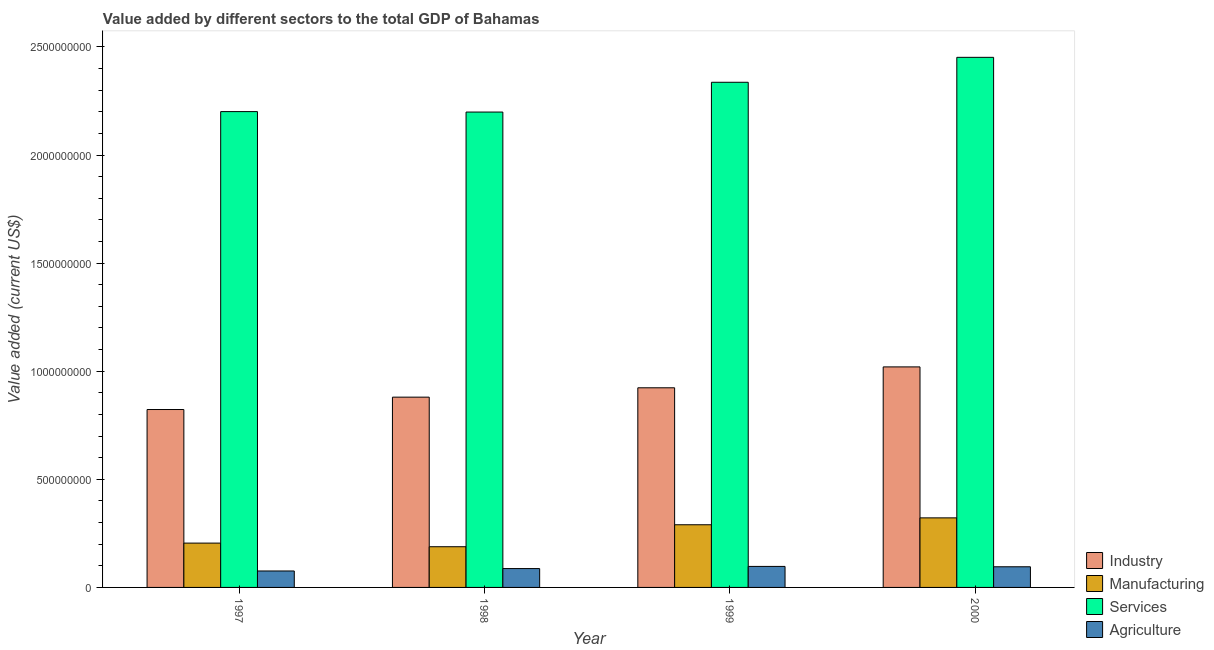How many groups of bars are there?
Offer a very short reply. 4. Are the number of bars on each tick of the X-axis equal?
Make the answer very short. Yes. How many bars are there on the 1st tick from the left?
Your answer should be compact. 4. How many bars are there on the 4th tick from the right?
Make the answer very short. 4. In how many cases, is the number of bars for a given year not equal to the number of legend labels?
Your answer should be compact. 0. What is the value added by industrial sector in 2000?
Give a very brief answer. 1.02e+09. Across all years, what is the maximum value added by agricultural sector?
Your response must be concise. 9.72e+07. Across all years, what is the minimum value added by agricultural sector?
Keep it short and to the point. 7.61e+07. In which year was the value added by manufacturing sector maximum?
Your answer should be very brief. 2000. What is the total value added by manufacturing sector in the graph?
Offer a very short reply. 1.00e+09. What is the difference between the value added by agricultural sector in 1997 and that in 2000?
Keep it short and to the point. -1.94e+07. What is the difference between the value added by manufacturing sector in 1998 and the value added by agricultural sector in 2000?
Your answer should be compact. -1.34e+08. What is the average value added by manufacturing sector per year?
Give a very brief answer. 2.51e+08. In the year 1997, what is the difference between the value added by agricultural sector and value added by industrial sector?
Your response must be concise. 0. What is the ratio of the value added by industrial sector in 1997 to that in 1998?
Your answer should be compact. 0.93. Is the difference between the value added by industrial sector in 1998 and 1999 greater than the difference between the value added by services sector in 1998 and 1999?
Give a very brief answer. No. What is the difference between the highest and the second highest value added by agricultural sector?
Ensure brevity in your answer.  1.66e+06. What is the difference between the highest and the lowest value added by agricultural sector?
Provide a short and direct response. 2.11e+07. Is the sum of the value added by manufacturing sector in 1999 and 2000 greater than the maximum value added by agricultural sector across all years?
Give a very brief answer. Yes. What does the 3rd bar from the left in 1997 represents?
Your answer should be very brief. Services. What does the 3rd bar from the right in 2000 represents?
Your response must be concise. Manufacturing. How many bars are there?
Your answer should be compact. 16. How many years are there in the graph?
Your answer should be very brief. 4. What is the difference between two consecutive major ticks on the Y-axis?
Provide a succinct answer. 5.00e+08. Does the graph contain grids?
Make the answer very short. No. How are the legend labels stacked?
Offer a terse response. Vertical. What is the title of the graph?
Your answer should be very brief. Value added by different sectors to the total GDP of Bahamas. Does "Financial sector" appear as one of the legend labels in the graph?
Ensure brevity in your answer.  No. What is the label or title of the Y-axis?
Provide a short and direct response. Value added (current US$). What is the Value added (current US$) in Industry in 1997?
Your answer should be very brief. 8.23e+08. What is the Value added (current US$) in Manufacturing in 1997?
Your answer should be compact. 2.05e+08. What is the Value added (current US$) in Services in 1997?
Ensure brevity in your answer.  2.20e+09. What is the Value added (current US$) of Agriculture in 1997?
Ensure brevity in your answer.  7.61e+07. What is the Value added (current US$) in Industry in 1998?
Your answer should be compact. 8.80e+08. What is the Value added (current US$) in Manufacturing in 1998?
Keep it short and to the point. 1.88e+08. What is the Value added (current US$) of Services in 1998?
Your response must be concise. 2.20e+09. What is the Value added (current US$) in Agriculture in 1998?
Keep it short and to the point. 8.72e+07. What is the Value added (current US$) of Industry in 1999?
Your response must be concise. 9.23e+08. What is the Value added (current US$) in Manufacturing in 1999?
Your answer should be very brief. 2.90e+08. What is the Value added (current US$) in Services in 1999?
Offer a terse response. 2.34e+09. What is the Value added (current US$) of Agriculture in 1999?
Ensure brevity in your answer.  9.72e+07. What is the Value added (current US$) of Industry in 2000?
Offer a terse response. 1.02e+09. What is the Value added (current US$) in Manufacturing in 2000?
Keep it short and to the point. 3.22e+08. What is the Value added (current US$) in Services in 2000?
Make the answer very short. 2.45e+09. What is the Value added (current US$) of Agriculture in 2000?
Give a very brief answer. 9.55e+07. Across all years, what is the maximum Value added (current US$) in Industry?
Your answer should be very brief. 1.02e+09. Across all years, what is the maximum Value added (current US$) in Manufacturing?
Ensure brevity in your answer.  3.22e+08. Across all years, what is the maximum Value added (current US$) of Services?
Your response must be concise. 2.45e+09. Across all years, what is the maximum Value added (current US$) of Agriculture?
Your response must be concise. 9.72e+07. Across all years, what is the minimum Value added (current US$) in Industry?
Make the answer very short. 8.23e+08. Across all years, what is the minimum Value added (current US$) of Manufacturing?
Provide a succinct answer. 1.88e+08. Across all years, what is the minimum Value added (current US$) of Services?
Give a very brief answer. 2.20e+09. Across all years, what is the minimum Value added (current US$) of Agriculture?
Offer a very short reply. 7.61e+07. What is the total Value added (current US$) in Industry in the graph?
Provide a succinct answer. 3.65e+09. What is the total Value added (current US$) of Manufacturing in the graph?
Give a very brief answer. 1.00e+09. What is the total Value added (current US$) in Services in the graph?
Keep it short and to the point. 9.19e+09. What is the total Value added (current US$) in Agriculture in the graph?
Ensure brevity in your answer.  3.56e+08. What is the difference between the Value added (current US$) in Industry in 1997 and that in 1998?
Offer a terse response. -5.72e+07. What is the difference between the Value added (current US$) of Manufacturing in 1997 and that in 1998?
Offer a terse response. 1.68e+07. What is the difference between the Value added (current US$) of Services in 1997 and that in 1998?
Provide a short and direct response. 2.08e+06. What is the difference between the Value added (current US$) in Agriculture in 1997 and that in 1998?
Keep it short and to the point. -1.11e+07. What is the difference between the Value added (current US$) of Industry in 1997 and that in 1999?
Keep it short and to the point. -1.00e+08. What is the difference between the Value added (current US$) in Manufacturing in 1997 and that in 1999?
Provide a short and direct response. -8.48e+07. What is the difference between the Value added (current US$) in Services in 1997 and that in 1999?
Give a very brief answer. -1.36e+08. What is the difference between the Value added (current US$) in Agriculture in 1997 and that in 1999?
Provide a short and direct response. -2.11e+07. What is the difference between the Value added (current US$) of Industry in 1997 and that in 2000?
Your answer should be compact. -1.97e+08. What is the difference between the Value added (current US$) in Manufacturing in 1997 and that in 2000?
Your response must be concise. -1.17e+08. What is the difference between the Value added (current US$) of Services in 1997 and that in 2000?
Your answer should be very brief. -2.51e+08. What is the difference between the Value added (current US$) of Agriculture in 1997 and that in 2000?
Your answer should be very brief. -1.94e+07. What is the difference between the Value added (current US$) of Industry in 1998 and that in 1999?
Make the answer very short. -4.33e+07. What is the difference between the Value added (current US$) of Manufacturing in 1998 and that in 1999?
Give a very brief answer. -1.02e+08. What is the difference between the Value added (current US$) in Services in 1998 and that in 1999?
Your answer should be compact. -1.38e+08. What is the difference between the Value added (current US$) of Agriculture in 1998 and that in 1999?
Offer a very short reply. -1.00e+07. What is the difference between the Value added (current US$) in Industry in 1998 and that in 2000?
Offer a very short reply. -1.40e+08. What is the difference between the Value added (current US$) in Manufacturing in 1998 and that in 2000?
Your response must be concise. -1.34e+08. What is the difference between the Value added (current US$) in Services in 1998 and that in 2000?
Offer a terse response. -2.53e+08. What is the difference between the Value added (current US$) in Agriculture in 1998 and that in 2000?
Offer a terse response. -8.35e+06. What is the difference between the Value added (current US$) of Industry in 1999 and that in 2000?
Make the answer very short. -9.66e+07. What is the difference between the Value added (current US$) of Manufacturing in 1999 and that in 2000?
Keep it short and to the point. -3.19e+07. What is the difference between the Value added (current US$) in Services in 1999 and that in 2000?
Offer a very short reply. -1.15e+08. What is the difference between the Value added (current US$) of Agriculture in 1999 and that in 2000?
Your response must be concise. 1.66e+06. What is the difference between the Value added (current US$) in Industry in 1997 and the Value added (current US$) in Manufacturing in 1998?
Your response must be concise. 6.35e+08. What is the difference between the Value added (current US$) of Industry in 1997 and the Value added (current US$) of Services in 1998?
Provide a succinct answer. -1.38e+09. What is the difference between the Value added (current US$) in Industry in 1997 and the Value added (current US$) in Agriculture in 1998?
Your answer should be compact. 7.36e+08. What is the difference between the Value added (current US$) of Manufacturing in 1997 and the Value added (current US$) of Services in 1998?
Give a very brief answer. -1.99e+09. What is the difference between the Value added (current US$) of Manufacturing in 1997 and the Value added (current US$) of Agriculture in 1998?
Provide a short and direct response. 1.18e+08. What is the difference between the Value added (current US$) in Services in 1997 and the Value added (current US$) in Agriculture in 1998?
Your answer should be compact. 2.11e+09. What is the difference between the Value added (current US$) of Industry in 1997 and the Value added (current US$) of Manufacturing in 1999?
Your answer should be compact. 5.33e+08. What is the difference between the Value added (current US$) of Industry in 1997 and the Value added (current US$) of Services in 1999?
Your response must be concise. -1.51e+09. What is the difference between the Value added (current US$) of Industry in 1997 and the Value added (current US$) of Agriculture in 1999?
Keep it short and to the point. 7.26e+08. What is the difference between the Value added (current US$) in Manufacturing in 1997 and the Value added (current US$) in Services in 1999?
Your answer should be very brief. -2.13e+09. What is the difference between the Value added (current US$) in Manufacturing in 1997 and the Value added (current US$) in Agriculture in 1999?
Provide a succinct answer. 1.08e+08. What is the difference between the Value added (current US$) in Services in 1997 and the Value added (current US$) in Agriculture in 1999?
Keep it short and to the point. 2.10e+09. What is the difference between the Value added (current US$) of Industry in 1997 and the Value added (current US$) of Manufacturing in 2000?
Your response must be concise. 5.01e+08. What is the difference between the Value added (current US$) of Industry in 1997 and the Value added (current US$) of Services in 2000?
Your answer should be compact. -1.63e+09. What is the difference between the Value added (current US$) of Industry in 1997 and the Value added (current US$) of Agriculture in 2000?
Give a very brief answer. 7.27e+08. What is the difference between the Value added (current US$) in Manufacturing in 1997 and the Value added (current US$) in Services in 2000?
Your response must be concise. -2.25e+09. What is the difference between the Value added (current US$) in Manufacturing in 1997 and the Value added (current US$) in Agriculture in 2000?
Your answer should be very brief. 1.09e+08. What is the difference between the Value added (current US$) of Services in 1997 and the Value added (current US$) of Agriculture in 2000?
Keep it short and to the point. 2.11e+09. What is the difference between the Value added (current US$) in Industry in 1998 and the Value added (current US$) in Manufacturing in 1999?
Keep it short and to the point. 5.90e+08. What is the difference between the Value added (current US$) in Industry in 1998 and the Value added (current US$) in Services in 1999?
Your answer should be compact. -1.46e+09. What is the difference between the Value added (current US$) of Industry in 1998 and the Value added (current US$) of Agriculture in 1999?
Ensure brevity in your answer.  7.83e+08. What is the difference between the Value added (current US$) in Manufacturing in 1998 and the Value added (current US$) in Services in 1999?
Your response must be concise. -2.15e+09. What is the difference between the Value added (current US$) in Manufacturing in 1998 and the Value added (current US$) in Agriculture in 1999?
Offer a terse response. 9.10e+07. What is the difference between the Value added (current US$) in Services in 1998 and the Value added (current US$) in Agriculture in 1999?
Your answer should be compact. 2.10e+09. What is the difference between the Value added (current US$) in Industry in 1998 and the Value added (current US$) in Manufacturing in 2000?
Provide a short and direct response. 5.58e+08. What is the difference between the Value added (current US$) in Industry in 1998 and the Value added (current US$) in Services in 2000?
Provide a succinct answer. -1.57e+09. What is the difference between the Value added (current US$) in Industry in 1998 and the Value added (current US$) in Agriculture in 2000?
Provide a short and direct response. 7.85e+08. What is the difference between the Value added (current US$) of Manufacturing in 1998 and the Value added (current US$) of Services in 2000?
Provide a succinct answer. -2.26e+09. What is the difference between the Value added (current US$) of Manufacturing in 1998 and the Value added (current US$) of Agriculture in 2000?
Provide a succinct answer. 9.27e+07. What is the difference between the Value added (current US$) of Services in 1998 and the Value added (current US$) of Agriculture in 2000?
Offer a terse response. 2.10e+09. What is the difference between the Value added (current US$) in Industry in 1999 and the Value added (current US$) in Manufacturing in 2000?
Ensure brevity in your answer.  6.02e+08. What is the difference between the Value added (current US$) of Industry in 1999 and the Value added (current US$) of Services in 2000?
Ensure brevity in your answer.  -1.53e+09. What is the difference between the Value added (current US$) in Industry in 1999 and the Value added (current US$) in Agriculture in 2000?
Provide a succinct answer. 8.28e+08. What is the difference between the Value added (current US$) of Manufacturing in 1999 and the Value added (current US$) of Services in 2000?
Make the answer very short. -2.16e+09. What is the difference between the Value added (current US$) in Manufacturing in 1999 and the Value added (current US$) in Agriculture in 2000?
Offer a very short reply. 1.94e+08. What is the difference between the Value added (current US$) in Services in 1999 and the Value added (current US$) in Agriculture in 2000?
Offer a very short reply. 2.24e+09. What is the average Value added (current US$) in Industry per year?
Your answer should be compact. 9.12e+08. What is the average Value added (current US$) of Manufacturing per year?
Provide a short and direct response. 2.51e+08. What is the average Value added (current US$) in Services per year?
Your answer should be compact. 2.30e+09. What is the average Value added (current US$) of Agriculture per year?
Your answer should be very brief. 8.90e+07. In the year 1997, what is the difference between the Value added (current US$) of Industry and Value added (current US$) of Manufacturing?
Ensure brevity in your answer.  6.18e+08. In the year 1997, what is the difference between the Value added (current US$) in Industry and Value added (current US$) in Services?
Provide a succinct answer. -1.38e+09. In the year 1997, what is the difference between the Value added (current US$) of Industry and Value added (current US$) of Agriculture?
Offer a terse response. 7.47e+08. In the year 1997, what is the difference between the Value added (current US$) of Manufacturing and Value added (current US$) of Services?
Make the answer very short. -2.00e+09. In the year 1997, what is the difference between the Value added (current US$) in Manufacturing and Value added (current US$) in Agriculture?
Offer a very short reply. 1.29e+08. In the year 1997, what is the difference between the Value added (current US$) of Services and Value added (current US$) of Agriculture?
Offer a very short reply. 2.12e+09. In the year 1998, what is the difference between the Value added (current US$) in Industry and Value added (current US$) in Manufacturing?
Your answer should be very brief. 6.92e+08. In the year 1998, what is the difference between the Value added (current US$) in Industry and Value added (current US$) in Services?
Offer a very short reply. -1.32e+09. In the year 1998, what is the difference between the Value added (current US$) of Industry and Value added (current US$) of Agriculture?
Offer a terse response. 7.93e+08. In the year 1998, what is the difference between the Value added (current US$) of Manufacturing and Value added (current US$) of Services?
Make the answer very short. -2.01e+09. In the year 1998, what is the difference between the Value added (current US$) of Manufacturing and Value added (current US$) of Agriculture?
Make the answer very short. 1.01e+08. In the year 1998, what is the difference between the Value added (current US$) in Services and Value added (current US$) in Agriculture?
Give a very brief answer. 2.11e+09. In the year 1999, what is the difference between the Value added (current US$) in Industry and Value added (current US$) in Manufacturing?
Your response must be concise. 6.33e+08. In the year 1999, what is the difference between the Value added (current US$) in Industry and Value added (current US$) in Services?
Provide a succinct answer. -1.41e+09. In the year 1999, what is the difference between the Value added (current US$) of Industry and Value added (current US$) of Agriculture?
Your answer should be compact. 8.26e+08. In the year 1999, what is the difference between the Value added (current US$) in Manufacturing and Value added (current US$) in Services?
Make the answer very short. -2.05e+09. In the year 1999, what is the difference between the Value added (current US$) of Manufacturing and Value added (current US$) of Agriculture?
Provide a short and direct response. 1.93e+08. In the year 1999, what is the difference between the Value added (current US$) of Services and Value added (current US$) of Agriculture?
Give a very brief answer. 2.24e+09. In the year 2000, what is the difference between the Value added (current US$) in Industry and Value added (current US$) in Manufacturing?
Your response must be concise. 6.98e+08. In the year 2000, what is the difference between the Value added (current US$) of Industry and Value added (current US$) of Services?
Your answer should be very brief. -1.43e+09. In the year 2000, what is the difference between the Value added (current US$) in Industry and Value added (current US$) in Agriculture?
Keep it short and to the point. 9.24e+08. In the year 2000, what is the difference between the Value added (current US$) of Manufacturing and Value added (current US$) of Services?
Ensure brevity in your answer.  -2.13e+09. In the year 2000, what is the difference between the Value added (current US$) in Manufacturing and Value added (current US$) in Agriculture?
Your response must be concise. 2.26e+08. In the year 2000, what is the difference between the Value added (current US$) of Services and Value added (current US$) of Agriculture?
Your response must be concise. 2.36e+09. What is the ratio of the Value added (current US$) of Industry in 1997 to that in 1998?
Offer a terse response. 0.94. What is the ratio of the Value added (current US$) in Manufacturing in 1997 to that in 1998?
Ensure brevity in your answer.  1.09. What is the ratio of the Value added (current US$) in Services in 1997 to that in 1998?
Provide a succinct answer. 1. What is the ratio of the Value added (current US$) in Agriculture in 1997 to that in 1998?
Your answer should be very brief. 0.87. What is the ratio of the Value added (current US$) of Industry in 1997 to that in 1999?
Keep it short and to the point. 0.89. What is the ratio of the Value added (current US$) in Manufacturing in 1997 to that in 1999?
Provide a short and direct response. 0.71. What is the ratio of the Value added (current US$) of Services in 1997 to that in 1999?
Your response must be concise. 0.94. What is the ratio of the Value added (current US$) in Agriculture in 1997 to that in 1999?
Make the answer very short. 0.78. What is the ratio of the Value added (current US$) of Industry in 1997 to that in 2000?
Ensure brevity in your answer.  0.81. What is the ratio of the Value added (current US$) of Manufacturing in 1997 to that in 2000?
Keep it short and to the point. 0.64. What is the ratio of the Value added (current US$) of Services in 1997 to that in 2000?
Make the answer very short. 0.9. What is the ratio of the Value added (current US$) of Agriculture in 1997 to that in 2000?
Ensure brevity in your answer.  0.8. What is the ratio of the Value added (current US$) in Industry in 1998 to that in 1999?
Provide a short and direct response. 0.95. What is the ratio of the Value added (current US$) in Manufacturing in 1998 to that in 1999?
Offer a very short reply. 0.65. What is the ratio of the Value added (current US$) in Services in 1998 to that in 1999?
Provide a succinct answer. 0.94. What is the ratio of the Value added (current US$) of Agriculture in 1998 to that in 1999?
Give a very brief answer. 0.9. What is the ratio of the Value added (current US$) in Industry in 1998 to that in 2000?
Offer a very short reply. 0.86. What is the ratio of the Value added (current US$) in Manufacturing in 1998 to that in 2000?
Provide a succinct answer. 0.58. What is the ratio of the Value added (current US$) in Services in 1998 to that in 2000?
Provide a succinct answer. 0.9. What is the ratio of the Value added (current US$) in Agriculture in 1998 to that in 2000?
Provide a succinct answer. 0.91. What is the ratio of the Value added (current US$) in Industry in 1999 to that in 2000?
Offer a very short reply. 0.91. What is the ratio of the Value added (current US$) in Manufacturing in 1999 to that in 2000?
Provide a succinct answer. 0.9. What is the ratio of the Value added (current US$) of Services in 1999 to that in 2000?
Offer a terse response. 0.95. What is the ratio of the Value added (current US$) of Agriculture in 1999 to that in 2000?
Your answer should be compact. 1.02. What is the difference between the highest and the second highest Value added (current US$) in Industry?
Provide a succinct answer. 9.66e+07. What is the difference between the highest and the second highest Value added (current US$) in Manufacturing?
Your answer should be compact. 3.19e+07. What is the difference between the highest and the second highest Value added (current US$) of Services?
Give a very brief answer. 1.15e+08. What is the difference between the highest and the second highest Value added (current US$) in Agriculture?
Ensure brevity in your answer.  1.66e+06. What is the difference between the highest and the lowest Value added (current US$) of Industry?
Provide a short and direct response. 1.97e+08. What is the difference between the highest and the lowest Value added (current US$) in Manufacturing?
Your response must be concise. 1.34e+08. What is the difference between the highest and the lowest Value added (current US$) of Services?
Keep it short and to the point. 2.53e+08. What is the difference between the highest and the lowest Value added (current US$) in Agriculture?
Offer a very short reply. 2.11e+07. 